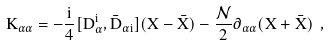Convert formula to latex. <formula><loc_0><loc_0><loc_500><loc_500>K _ { \alpha { \dot { \alpha } } } = - \frac { i } { 4 } [ D _ { \alpha } ^ { \mathbf i } , { \bar { D } } _ { { \dot { \alpha } } { \mathbf i } } ] ( X - { \bar { X } } ) - \frac { \mathcal { N } } { 2 } \partial _ { \alpha { \dot { \alpha } } } ( X + { \bar { X } } ) \ ,</formula> 